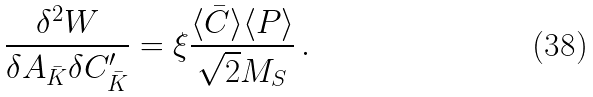<formula> <loc_0><loc_0><loc_500><loc_500>\frac { \delta ^ { 2 } W } { \delta A _ { \bar { K } } \delta C ^ { \prime } _ { \bar { K } } } = \xi \frac { \langle \bar { C } \rangle \langle P \rangle } { \sqrt { 2 } M _ { S } } \, .</formula> 